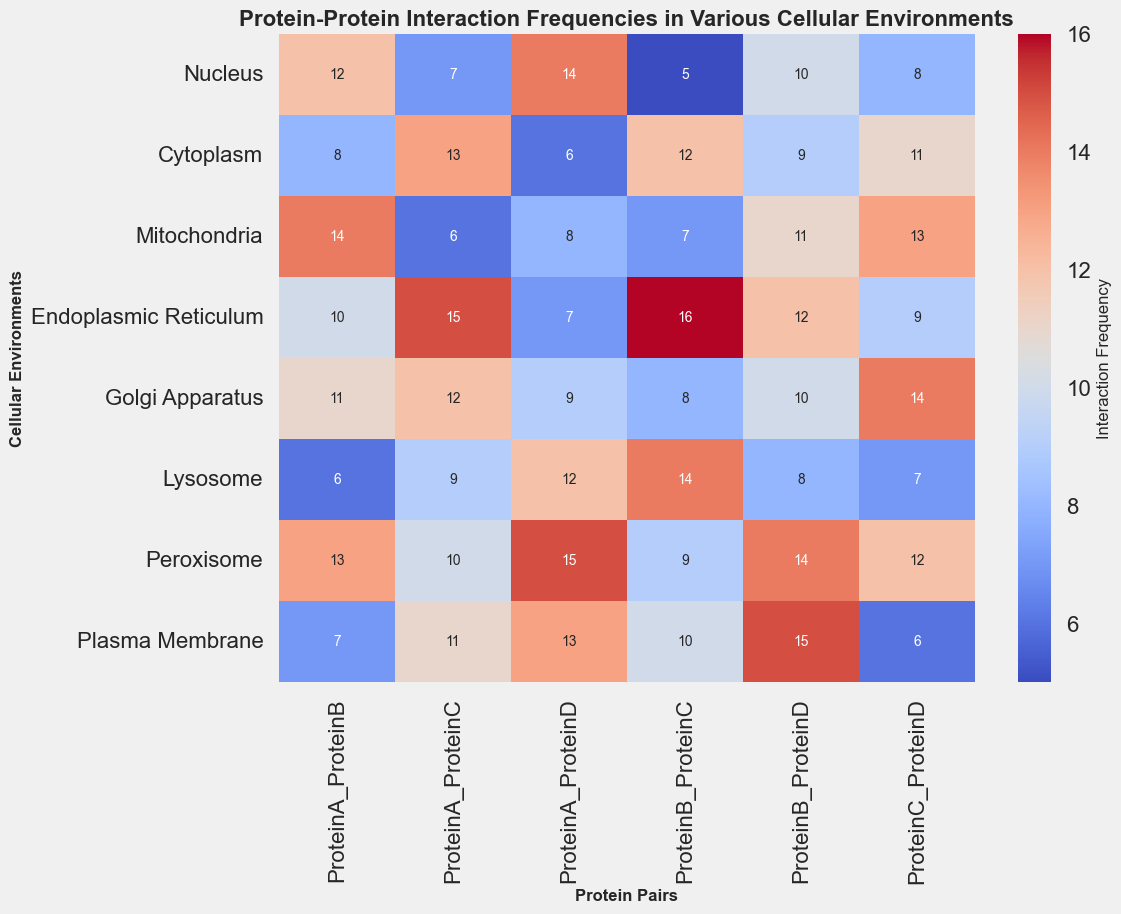What's the highest interaction frequency for ProteinA_ProteinC? To find the highest interaction frequency for ProteinA_ProteinC, look at the data values in the column "ProteinA_ProteinC" for all cellular environments and identify the maximum value, which is 15 in the Endoplasmic Reticulum.
Answer: 15 Which cellular environment shows the lowest interaction frequency for ProteinB_ProteinD? Check the column "ProteinB_ProteinD" and find the smallest value, which is 8 in the Lysosome.
Answer: Lysosome What's the total interaction frequency of ProteinA_ProteinB across all cellular environments? Sum the values in the "ProteinA_ProteinB" column: 12 + 8 + 14 + 10 + 11 + 6 + 13 + 7 = 81.
Answer: 81 Which cell compartment has the highest average interaction frequency across all protein pairs? Calculate the average for each row. Endoplasmic Reticulum has the highest sum (10+15+7+16+12+9=69), and its average is highest (69/6=11.5).
Answer: Endoplasmic Reticulum Compare the interaction frequency of ProteinA_ProteinD in the Mitochondria and Plasma Membrane. Which one is greater? Look at the values for ProteinA_ProteinD in "Mitochondria" (8) and "Plasma Membrane" (13). 13 is greater.
Answer: Plasma Membrane What are the interaction frequencies of ProteinC_ProteinD in the Cytoplasm and Golgi Apparatus, and what is their difference? Check the values for ProteinC_ProteinD in "Cytoplasm" (11) and "Golgi Apparatus" (14). The difference is 14 - 11 = 3.
Answer: 3 Which cellular environment has the darkest shade of red for ProteinB_ProteinC? The darkest shade of red represents the highest value. For ProteinB_ProteinC, the highest value is in the Endoplasmic Reticulum with a frequency of 16.
Answer: Endoplasmic Reticulum 